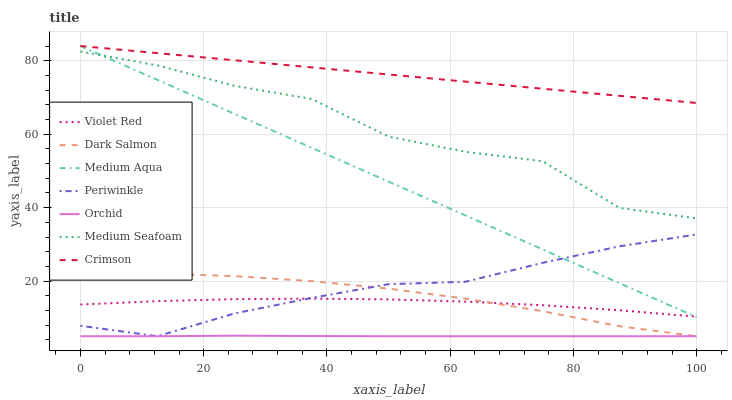Does Orchid have the minimum area under the curve?
Answer yes or no. Yes. Does Crimson have the maximum area under the curve?
Answer yes or no. Yes. Does Dark Salmon have the minimum area under the curve?
Answer yes or no. No. Does Dark Salmon have the maximum area under the curve?
Answer yes or no. No. Is Medium Aqua the smoothest?
Answer yes or no. Yes. Is Medium Seafoam the roughest?
Answer yes or no. Yes. Is Dark Salmon the smoothest?
Answer yes or no. No. Is Dark Salmon the roughest?
Answer yes or no. No. Does Dark Salmon have the lowest value?
Answer yes or no. Yes. Does Crimson have the lowest value?
Answer yes or no. No. Does Medium Aqua have the highest value?
Answer yes or no. Yes. Does Dark Salmon have the highest value?
Answer yes or no. No. Is Orchid less than Crimson?
Answer yes or no. Yes. Is Crimson greater than Medium Seafoam?
Answer yes or no. Yes. Does Medium Aqua intersect Crimson?
Answer yes or no. Yes. Is Medium Aqua less than Crimson?
Answer yes or no. No. Is Medium Aqua greater than Crimson?
Answer yes or no. No. Does Orchid intersect Crimson?
Answer yes or no. No. 